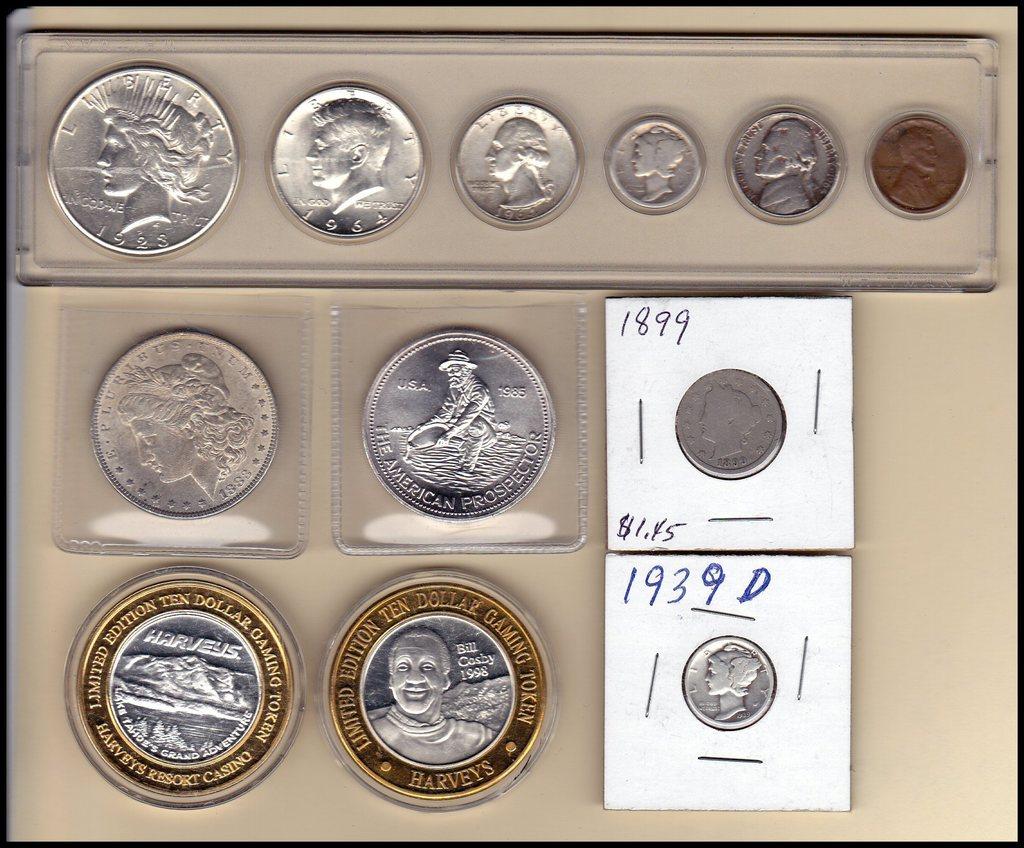What year is the bottom coin on the right made in?
Keep it short and to the point. 1939. What year is on the coin in the top left?
Offer a terse response. 1928. 